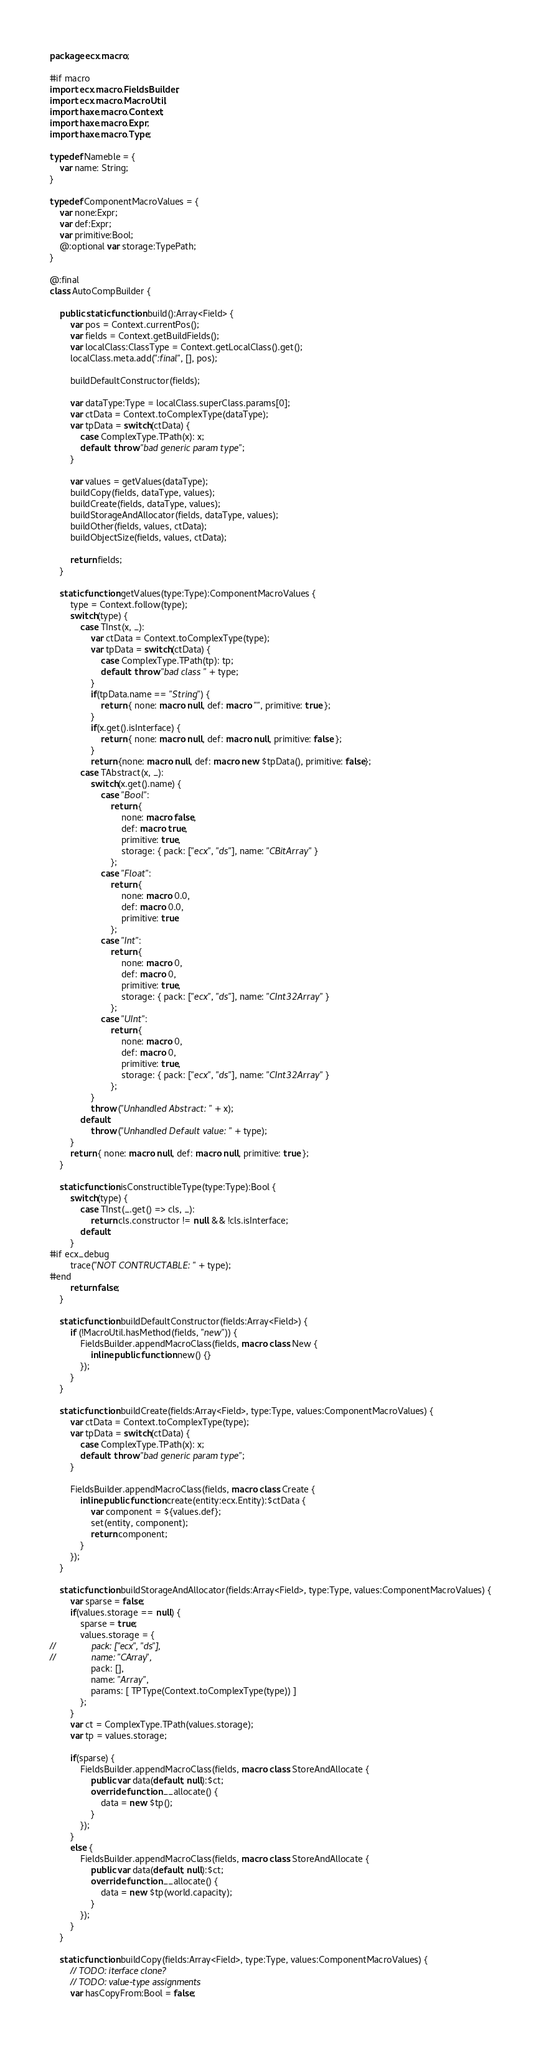Convert code to text. <code><loc_0><loc_0><loc_500><loc_500><_Haxe_>package ecx.macro;

#if macro
import ecx.macro.FieldsBuilder;
import ecx.macro.MacroUtil;
import haxe.macro.Context;
import haxe.macro.Expr;
import haxe.macro.Type;

typedef Nameble = {
	var name: String;
}

typedef ComponentMacroValues = {
	var none:Expr;
	var def:Expr;
	var primitive:Bool;
	@:optional var storage:TypePath;
}

@:final
class AutoCompBuilder {

	public static function build():Array<Field> {
		var pos = Context.currentPos();
		var fields = Context.getBuildFields();
		var localClass:ClassType = Context.getLocalClass().get();
		localClass.meta.add(":final", [], pos);
		
		buildDefaultConstructor(fields);

		var dataType:Type = localClass.superClass.params[0];
		var ctData = Context.toComplexType(dataType);
		var tpData = switch(ctData) {
			case ComplexType.TPath(x): x;
			default: throw "bad generic param type";
		}

		var values = getValues(dataType);
		buildCopy(fields, dataType, values);
		buildCreate(fields, dataType, values);
		buildStorageAndAllocator(fields, dataType, values);
		buildOther(fields, values, ctData);
		buildObjectSize(fields, values, ctData);

		return fields;
	}

	static function getValues(type:Type):ComponentMacroValues {
		type = Context.follow(type);
		switch(type) {
			case TInst(x, _):
				var ctData = Context.toComplexType(type);
				var tpData = switch(ctData) {
					case ComplexType.TPath(tp): tp;
					default: throw "bad class " + type;
				}
				if(tpData.name == "String") {
					return { none: macro null, def: macro "", primitive: true };
				}
				if(x.get().isInterface) {
					return { none: macro null, def: macro null, primitive: false };
				}
				return {none: macro null, def: macro new $tpData(), primitive: false};
			case TAbstract(x, _):
				switch(x.get().name) {
					case "Bool":
						return {
							none: macro false,
							def: macro true,
							primitive: true,
							storage: { pack: ["ecx", "ds"], name: "CBitArray" }
						};
					case "Float":
						return {
							none: macro 0.0,
							def: macro 0.0,
							primitive: true
						};
					case "Int":
						return {
							none: macro 0,
							def: macro 0,
							primitive: true,
							storage: { pack: ["ecx", "ds"], name: "CInt32Array" }
						};
					case "UInt":
						return {
							none: macro 0,
							def: macro 0,
							primitive: true,
							storage: { pack: ["ecx", "ds"], name: "CInt32Array" }
						};
				}
				throw ("Unhandled Abstract: " + x);
			default:
				throw ("Unhandled Default value: " + type);
		}
		return { none: macro null, def: macro null, primitive: true };
	}

	static function isConstructibleType(type:Type):Bool {
		switch(type) {
			case TInst(_.get() => cls, _):
				return cls.constructor != null && !cls.isInterface;
			default:
		}
#if ecx_debug
		trace("NOT CONTRUCTABLE: " + type);
#end
		return false;
	}

	static function buildDefaultConstructor(fields:Array<Field>) {
		if (!MacroUtil.hasMethod(fields, "new")) {
			FieldsBuilder.appendMacroClass(fields, macro class New {
				inline public function new() {}
			});
		}
	}

	static function buildCreate(fields:Array<Field>, type:Type, values:ComponentMacroValues) {
		var ctData = Context.toComplexType(type);
		var tpData = switch(ctData) {
			case ComplexType.TPath(x): x;
			default: throw "bad generic param type";
		}

		FieldsBuilder.appendMacroClass(fields, macro class Create {
			inline public function create(entity:ecx.Entity):$ctData {
				var component = ${values.def};
				set(entity, component);
				return component;
			}
		});
	}

	static function buildStorageAndAllocator(fields:Array<Field>, type:Type, values:ComponentMacroValues) {
		var sparse = false;
		if(values.storage == null) {
			sparse = true;
			values.storage = {
//				pack: ["ecx", "ds"],
//				name: "CArray",
				pack: [],
				name: "Array",
				params: [ TPType(Context.toComplexType(type)) ]
			};
		}
		var ct = ComplexType.TPath(values.storage);
		var tp = values.storage;

		if(sparse) {
			FieldsBuilder.appendMacroClass(fields, macro class StoreAndAllocate {
				public var data(default, null):$ct;
				override function __allocate() {
					data = new $tp();
				}
			});
		}
		else {
			FieldsBuilder.appendMacroClass(fields, macro class StoreAndAllocate {
				public var data(default, null):$ct;
				override function __allocate() {
					data = new $tp(world.capacity);
				}
			});
		}
	}

	static function buildCopy(fields:Array<Field>, type:Type, values:ComponentMacroValues) {
		// TODO: iterface clone?
		// TODO: value-type assignments
		var hasCopyFrom:Bool = false;</code> 